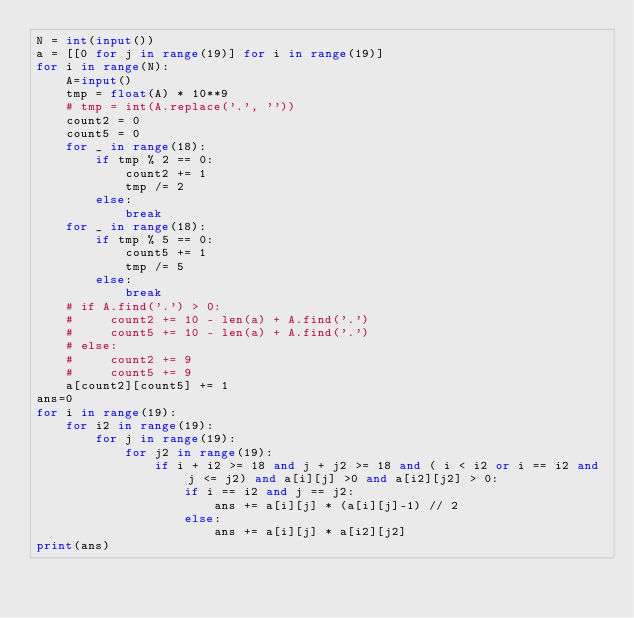Convert code to text. <code><loc_0><loc_0><loc_500><loc_500><_Python_>N = int(input())
a = [[0 for j in range(19)] for i in range(19)]
for i in range(N):
    A=input()
    tmp = float(A) * 10**9
    # tmp = int(A.replace('.', ''))
    count2 = 0
    count5 = 0
    for _ in range(18):
        if tmp % 2 == 0:
            count2 += 1
            tmp /= 2
        else:
            break
    for _ in range(18):
        if tmp % 5 == 0:
            count5 += 1
            tmp /= 5
        else:
            break
    # if A.find('.') > 0:
    #     count2 += 10 - len(a) + A.find('.')
    #     count5 += 10 - len(a) + A.find('.')
    # else:
    #     count2 += 9
    #     count5 += 9
    a[count2][count5] += 1
ans=0
for i in range(19):
    for i2 in range(19):
        for j in range(19):
            for j2 in range(19):
                if i + i2 >= 18 and j + j2 >= 18 and ( i < i2 or i == i2 and j <= j2) and a[i][j] >0 and a[i2][j2] > 0:
                    if i == i2 and j == j2:
                        ans += a[i][j] * (a[i][j]-1) // 2
                    else:
                        ans += a[i][j] * a[i2][j2]
print(ans)
</code> 